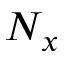Convert formula to latex. <formula><loc_0><loc_0><loc_500><loc_500>N _ { x }</formula> 